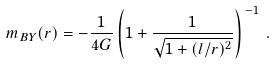Convert formula to latex. <formula><loc_0><loc_0><loc_500><loc_500>m _ { B Y } ( r ) = - \frac { 1 } { 4 G } \left ( 1 + \frac { 1 } { \sqrt { 1 + ( l / r ) ^ { 2 } } } \right ) ^ { \, - 1 } \, .</formula> 